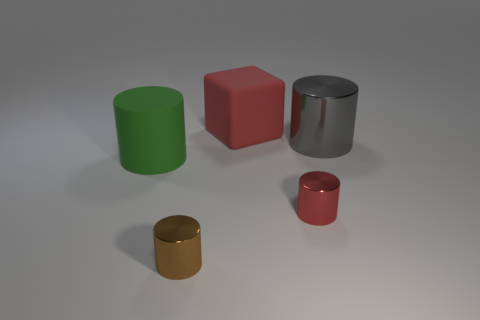There is a thing that is both on the left side of the large cube and behind the red metal cylinder; what shape is it?
Provide a short and direct response. Cylinder. Is there a blue shiny ball of the same size as the matte cube?
Offer a terse response. No. There is a shiny thing behind the big green matte object; is its shape the same as the brown object?
Give a very brief answer. Yes. Is the green object the same shape as the tiny brown metallic object?
Ensure brevity in your answer.  Yes. Are there any brown things that have the same shape as the big gray shiny thing?
Keep it short and to the point. Yes. What is the shape of the red object behind the metal cylinder behind the green matte object?
Your answer should be very brief. Cube. There is a cylinder behind the large green cylinder; what is its color?
Make the answer very short. Gray. What is the size of the gray cylinder that is made of the same material as the brown object?
Offer a terse response. Large. The other rubber object that is the same shape as the big gray object is what size?
Make the answer very short. Large. Are there any red cylinders?
Keep it short and to the point. Yes. 